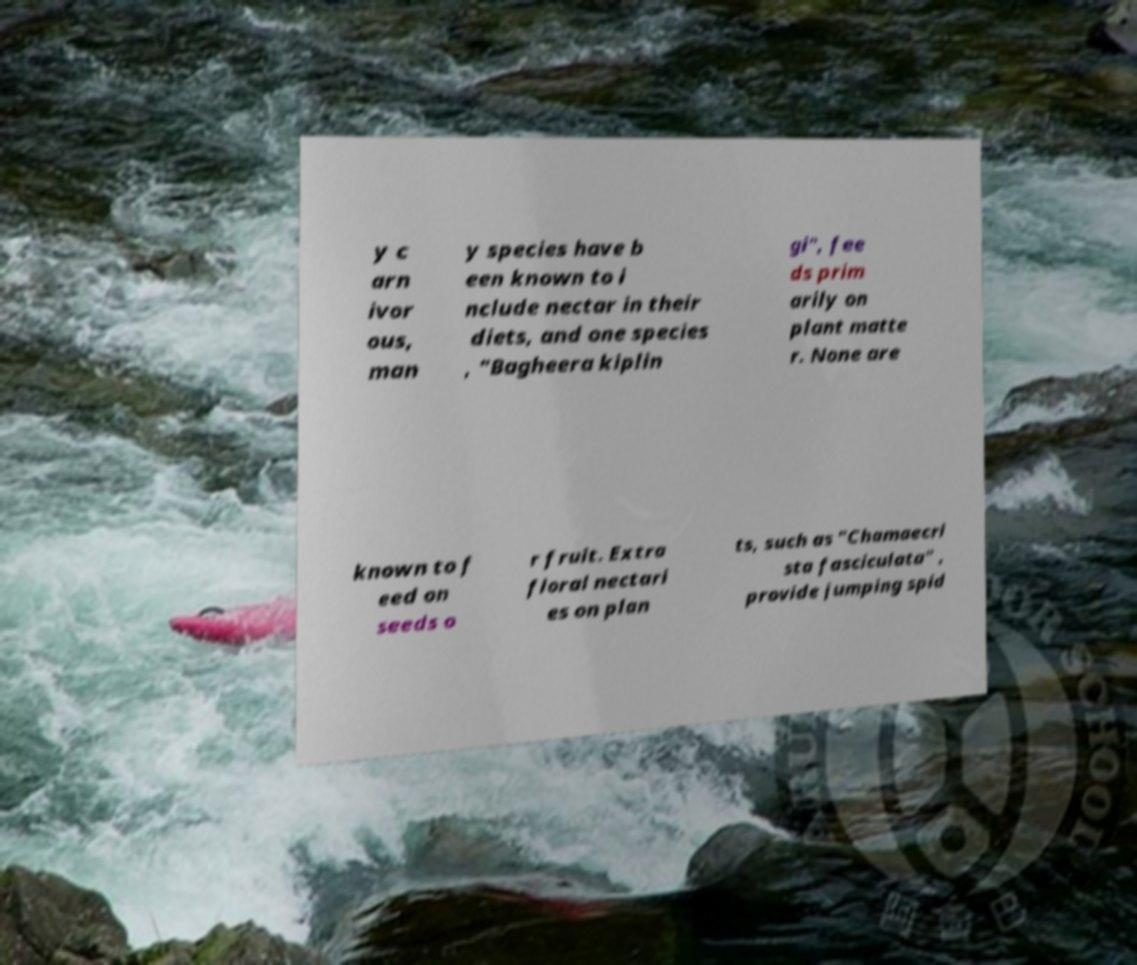Can you read and provide the text displayed in the image?This photo seems to have some interesting text. Can you extract and type it out for me? y c arn ivor ous, man y species have b een known to i nclude nectar in their diets, and one species , "Bagheera kiplin gi", fee ds prim arily on plant matte r. None are known to f eed on seeds o r fruit. Extra floral nectari es on plan ts, such as "Chamaecri sta fasciculata" , provide jumping spid 